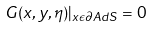Convert formula to latex. <formula><loc_0><loc_0><loc_500><loc_500>G ( x , y , \eta ) | _ { x \epsilon \partial A d S } = 0</formula> 